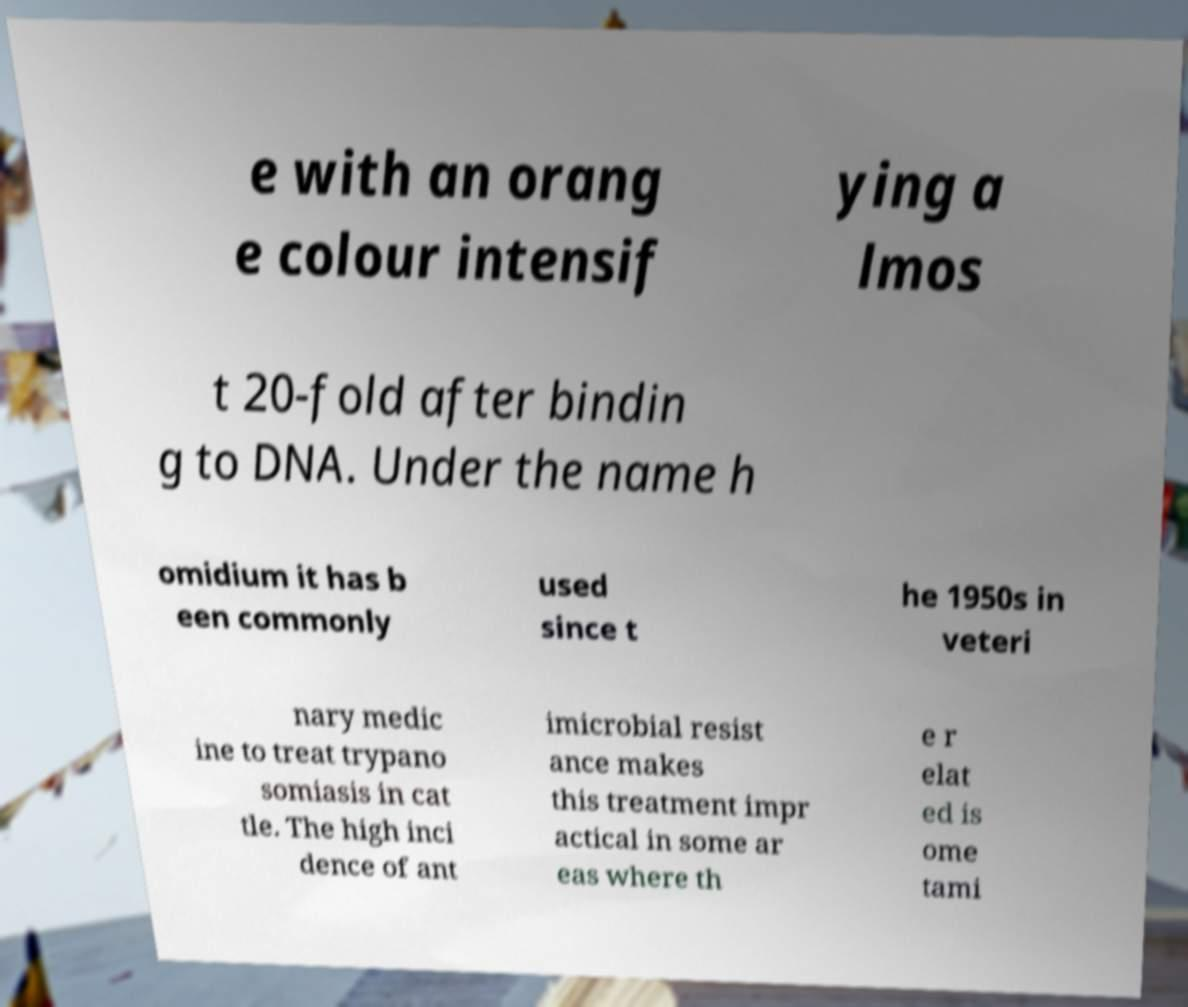What messages or text are displayed in this image? I need them in a readable, typed format. e with an orang e colour intensif ying a lmos t 20-fold after bindin g to DNA. Under the name h omidium it has b een commonly used since t he 1950s in veteri nary medic ine to treat trypano somiasis in cat tle. The high inci dence of ant imicrobial resist ance makes this treatment impr actical in some ar eas where th e r elat ed is ome tami 